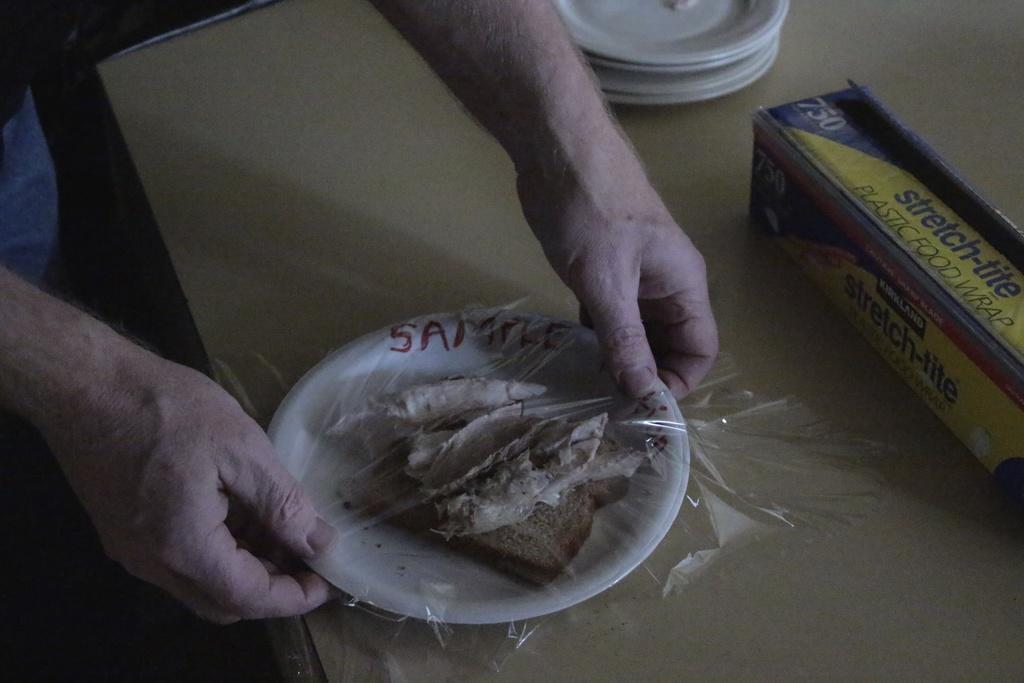What is being held by the person's hands in the image? There is a person's hands holding a plate in the image. What is on the plate that is being held? The plate contains a food item and a cover. What can be seen on the surface in the image? The surface contains objects, including plates and a cardboard box. How many cracks can be seen on the plate in the image? There are no cracks visible on the plate in the image. What type of currency is present on the surface in the image? There is no currency, such as a dime, present on the surface in the image. 